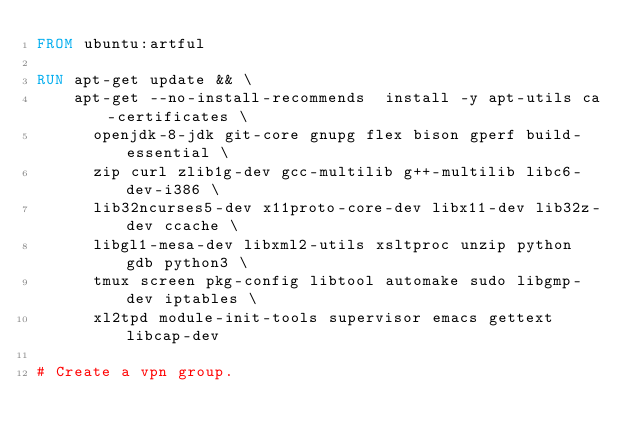<code> <loc_0><loc_0><loc_500><loc_500><_Dockerfile_>FROM ubuntu:artful

RUN apt-get update && \
    apt-get --no-install-recommends  install -y apt-utils ca-certificates \
      openjdk-8-jdk git-core gnupg flex bison gperf build-essential \
      zip curl zlib1g-dev gcc-multilib g++-multilib libc6-dev-i386 \
      lib32ncurses5-dev x11proto-core-dev libx11-dev lib32z-dev ccache \
      libgl1-mesa-dev libxml2-utils xsltproc unzip python gdb python3 \
      tmux screen pkg-config libtool automake sudo libgmp-dev iptables \
      xl2tpd module-init-tools supervisor emacs gettext libcap-dev

# Create a vpn group.</code> 